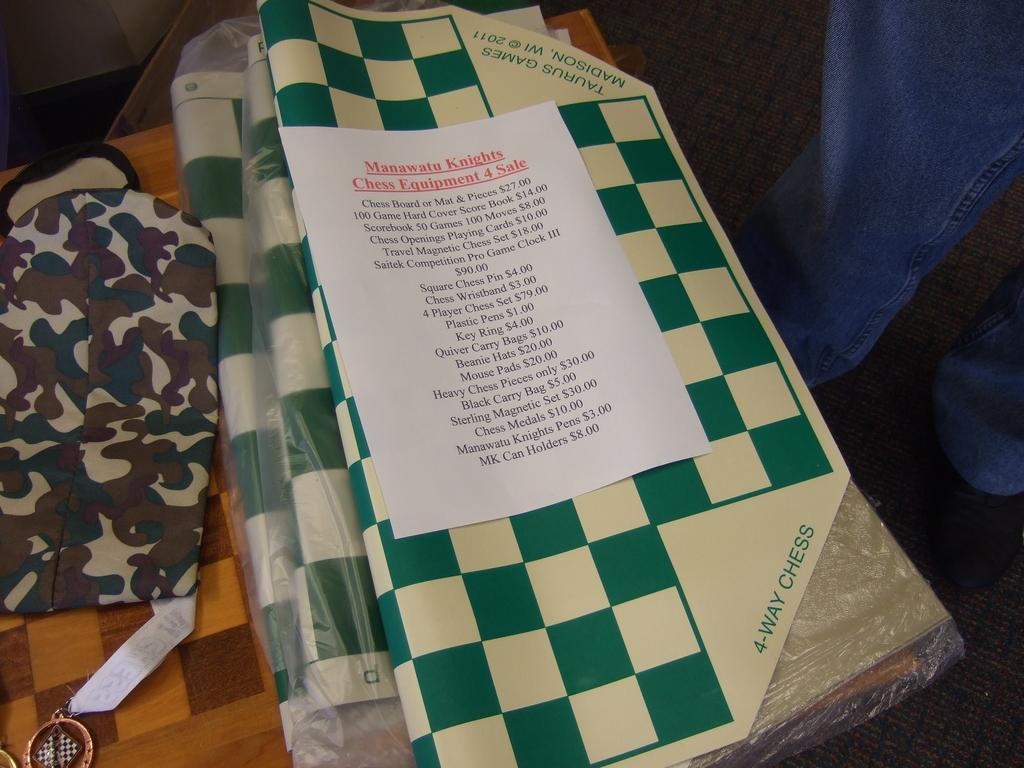Could you give a brief overview of what you see in this image? In this image we can see few objects on the table. We can see the legs of a person at the right side of the image. There is some text on the paper in the image. 